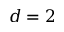<formula> <loc_0><loc_0><loc_500><loc_500>d = 2</formula> 